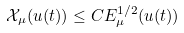Convert formula to latex. <formula><loc_0><loc_0><loc_500><loc_500>\mathcal { X } _ { \mu } ( u ( t ) ) \leq C E _ { \mu } ^ { 1 / 2 } ( u ( t ) )</formula> 